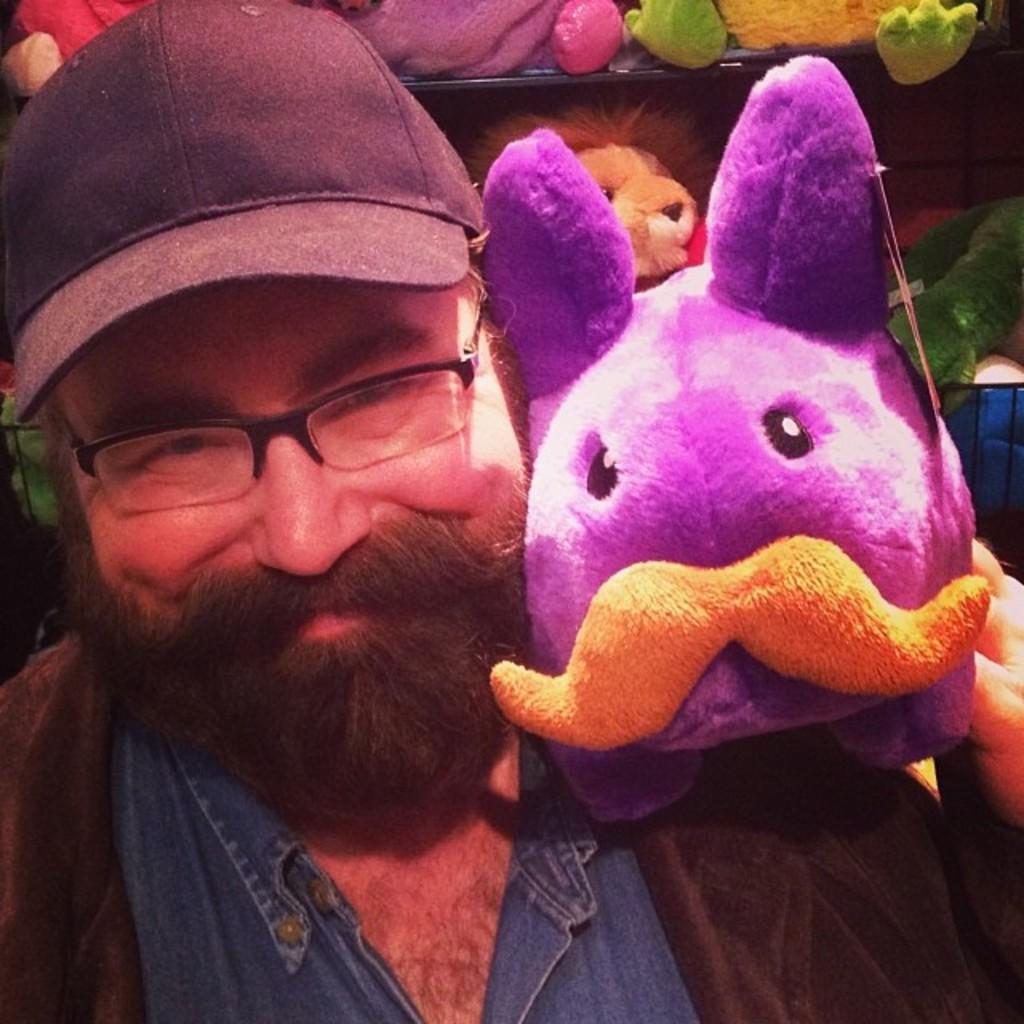How would you summarize this image in a sentence or two? In this picture we can see a man, he wore a cap, there are some dolls here. 